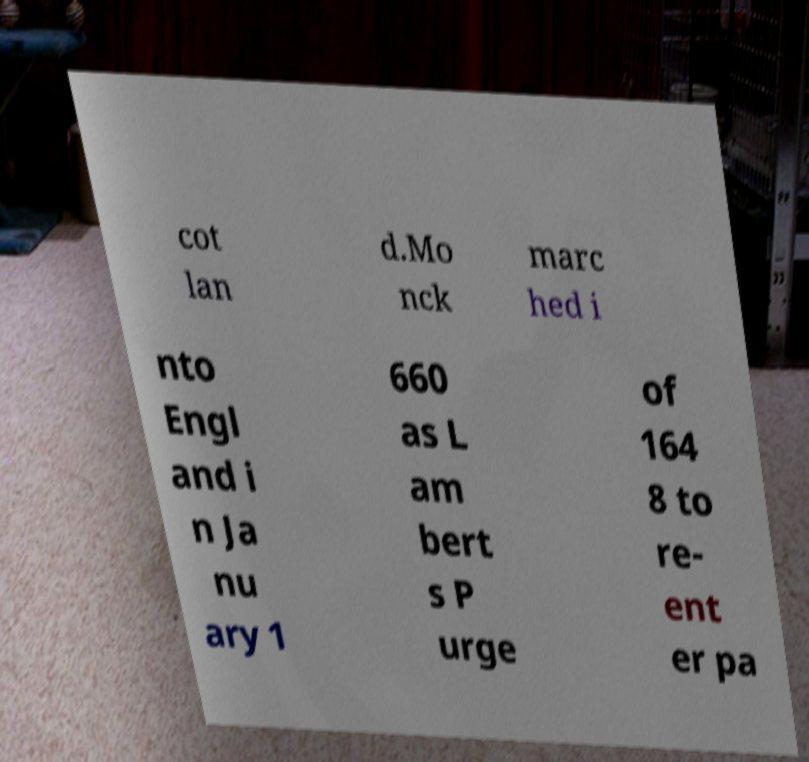Can you accurately transcribe the text from the provided image for me? cot lan d.Mo nck marc hed i nto Engl and i n Ja nu ary 1 660 as L am bert s P urge of 164 8 to re- ent er pa 